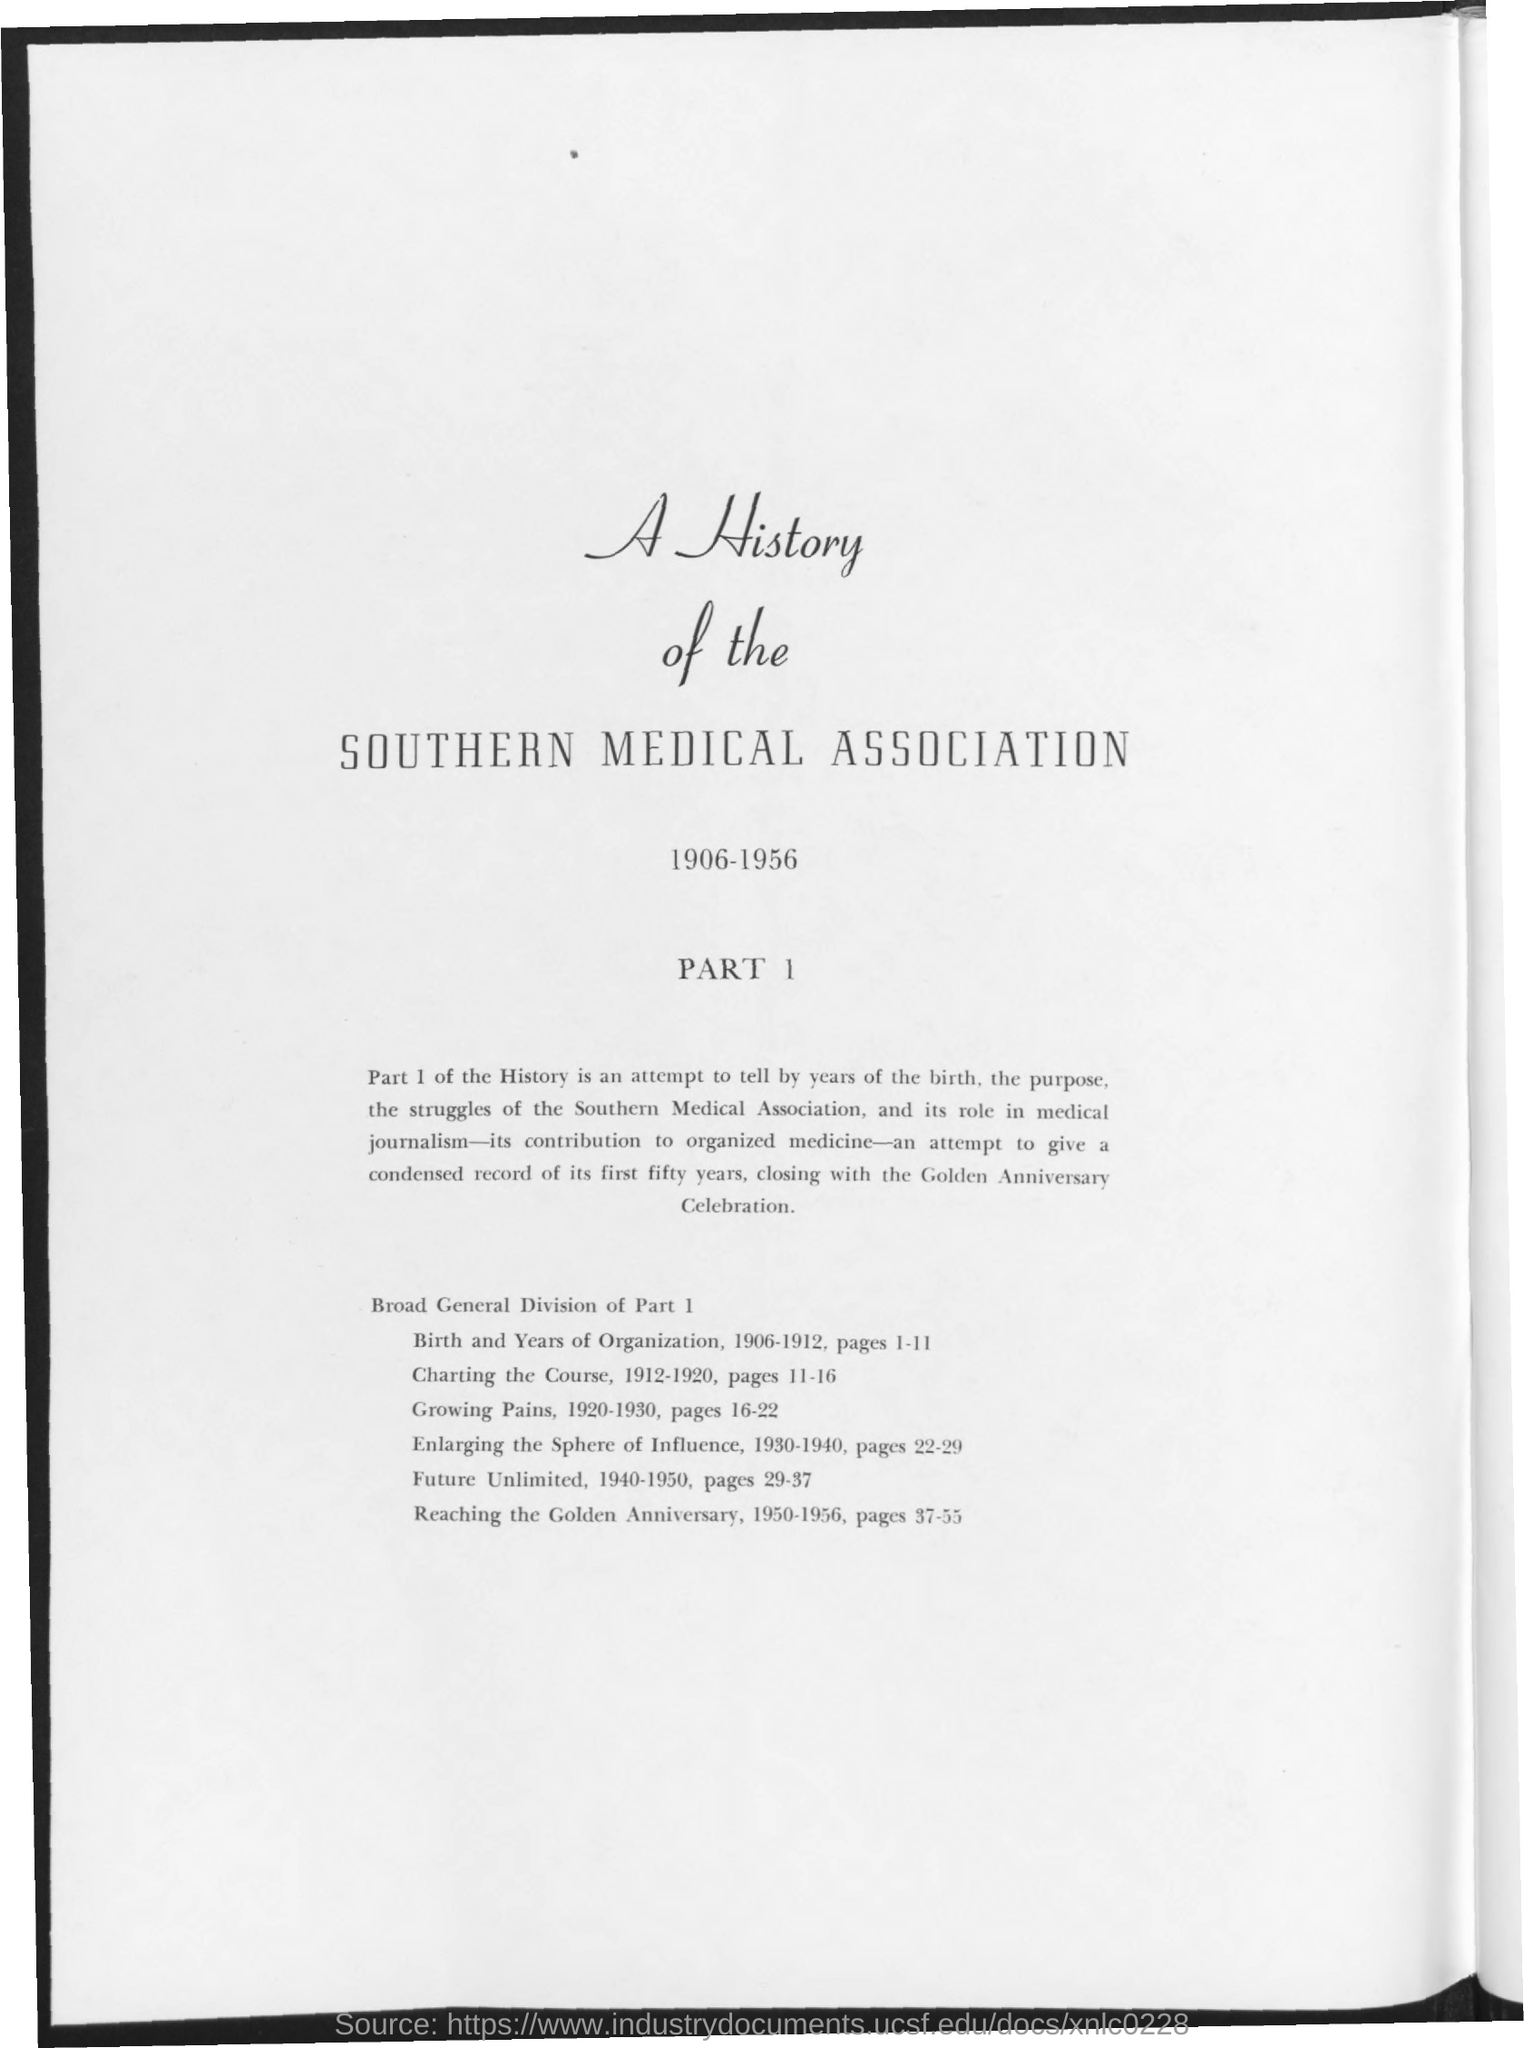Give some essential details in this illustration. The title of the document is 'A History of the Southern Medical Association'. The range of years mentioned in the document is 1906-1956. 